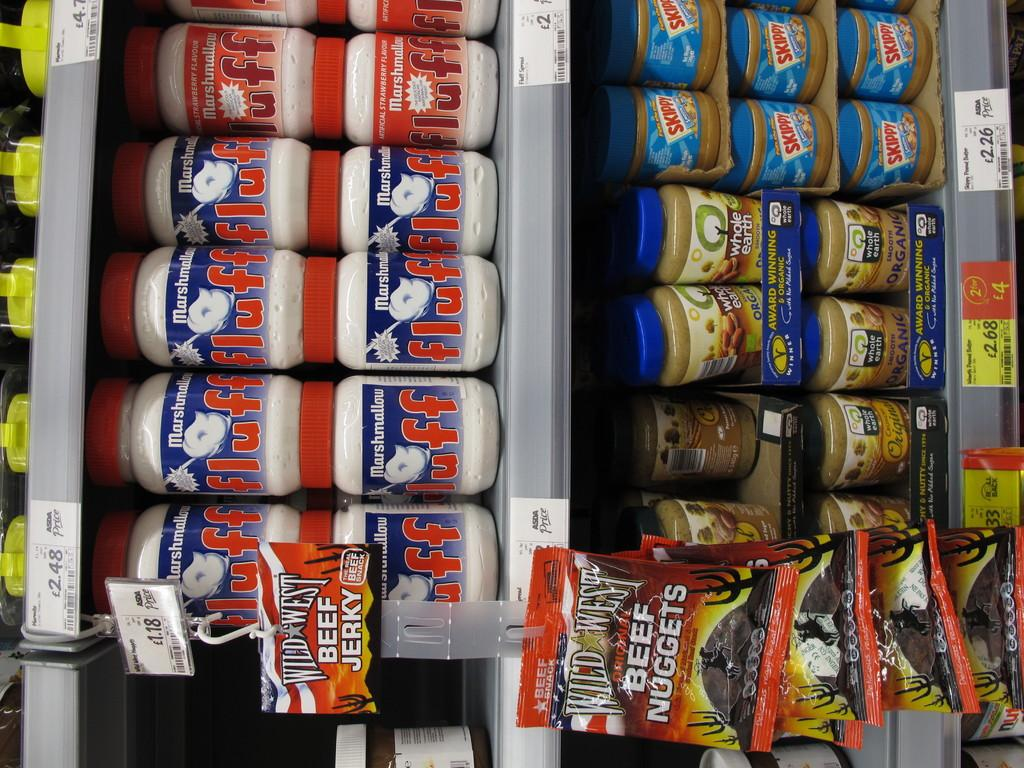<image>
Share a concise interpretation of the image provided. A store display of skippy peanut butter and other items. 